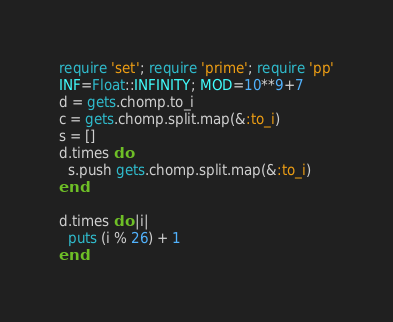<code> <loc_0><loc_0><loc_500><loc_500><_Ruby_>require 'set'; require 'prime'; require 'pp'
INF=Float::INFINITY; MOD=10**9+7
d = gets.chomp.to_i
c = gets.chomp.split.map(&:to_i)
s = []
d.times do
  s.push gets.chomp.split.map(&:to_i)
end

d.times do |i|
  puts (i % 26) + 1
end
</code> 